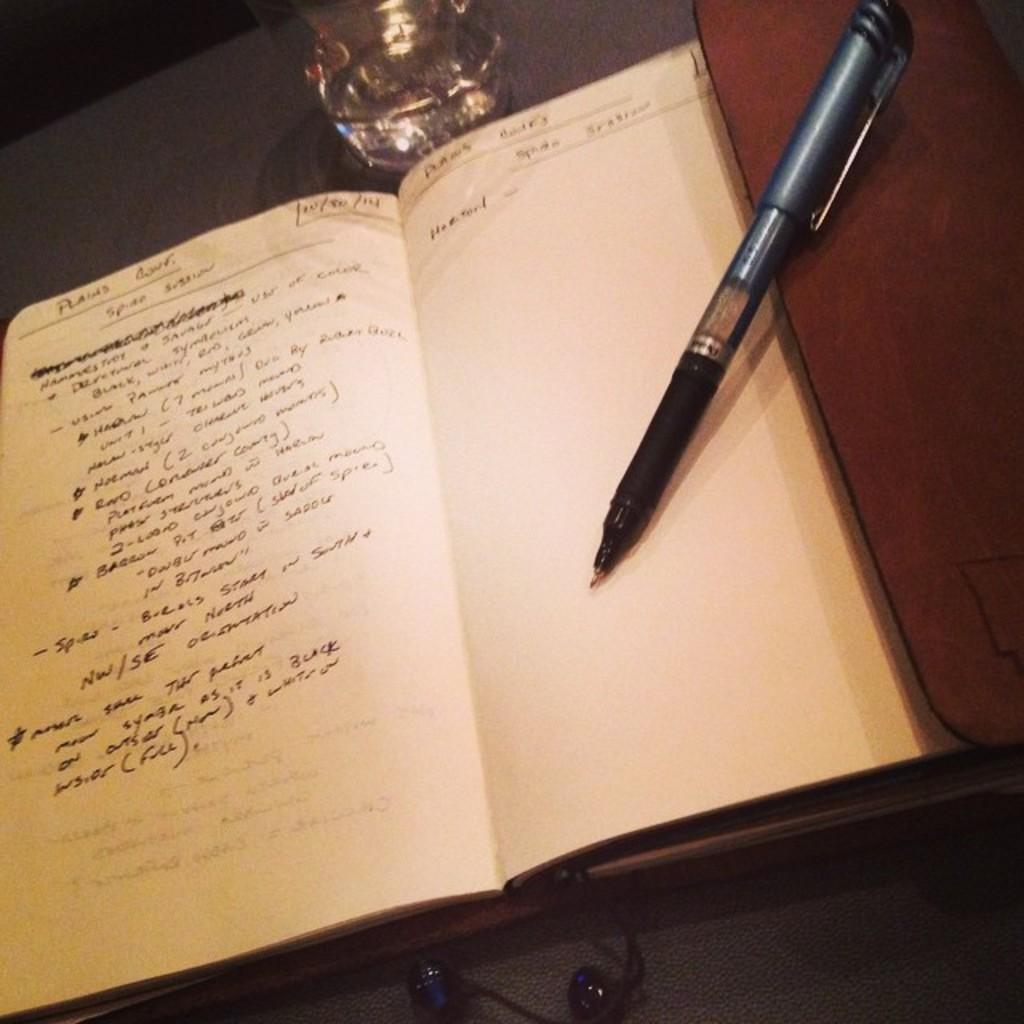What is the main object in the image? There is a book with white color papers in the image. What can be seen on the right side of the image? There is a pen on the right side of the image. What is located at the top of the image? There is a bottle on the top of the image. What type of weather can be seen in the image? There is no weather depicted in the image; it is a still image of objects on a surface. 